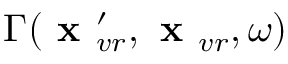<formula> <loc_0><loc_0><loc_500><loc_500>\Gamma ( x _ { v r } ^ { \prime } , x _ { v r } , \omega )</formula> 